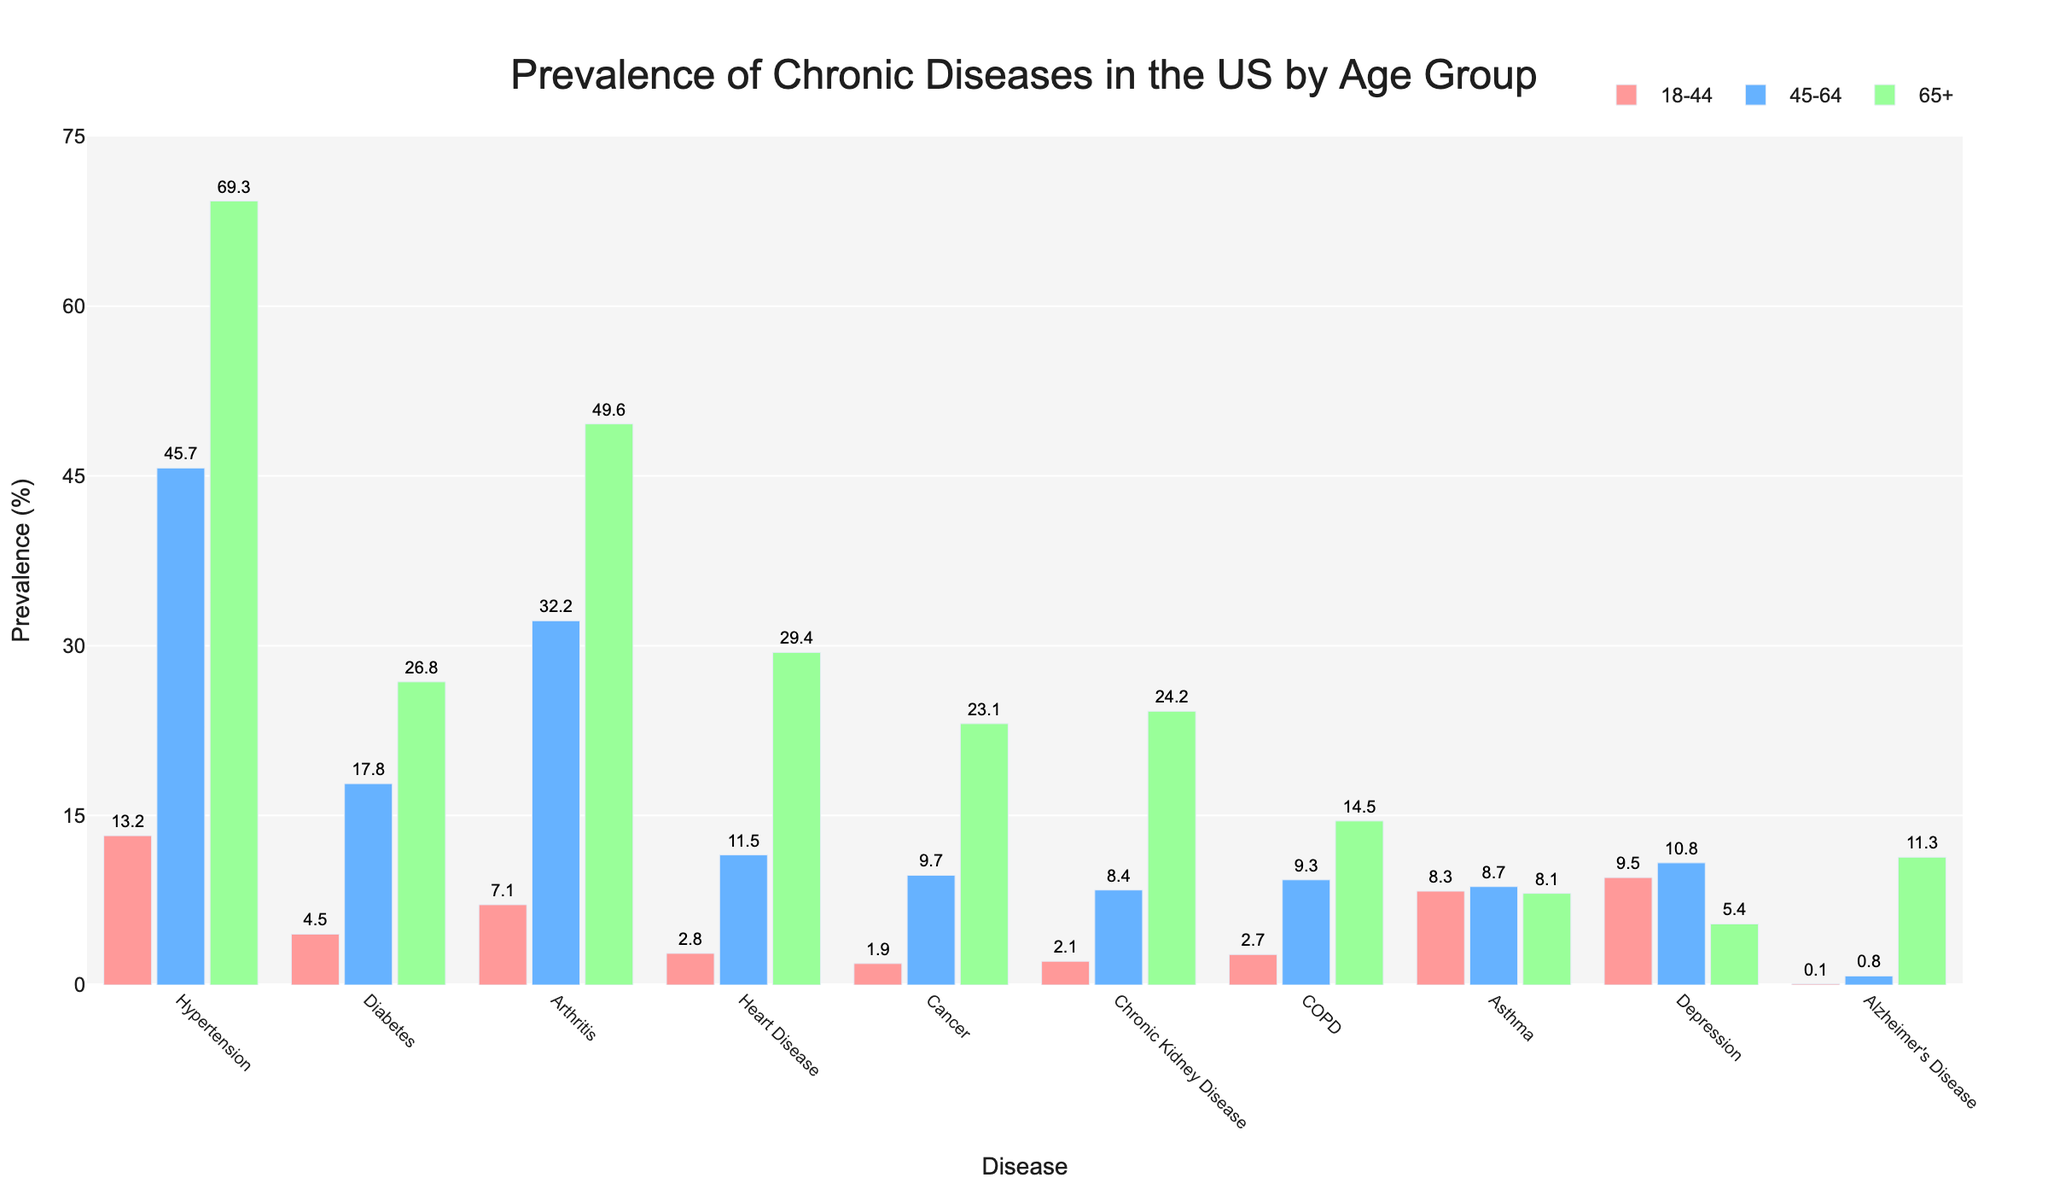Which age group has the highest prevalence of hypertension? Look for the tallest bar under the "Hypertension" category for each age group. The tallest bar corresponds to the 65+ age group.
Answer: 65+ What is the difference in asthma prevalence between the 18-44 and 65+ age groups? Identify the heights of the bars for "Asthma" under the 18-44 and 65+ age groups. The values are 8.3 for 18-44 and 8.1 for 65+. Subtract the two values: 8.3 - 8.1 = 0.2.
Answer: 0.2 Which disease has the smallest prevalence in the 45-64 age group, and what is that prevalence? Find the shortest bar within the 45-64 age group. "Alzheimer's Disease" has the shortest bar with a prevalence of 0.8.
Answer: Alzheimer's Disease, 0.8 How many diseases have a prevalence greater than 10% in the 65+ age group? Count the number of diseases with bars exceeding the 10% mark in the 65+ age group: Hypertension, Diabetes, Arthritis, Heart Disease, Cancer, Chronic Kidney Disease, COPD, Alzheimer's Disease. There are eight such diseases.
Answer: 8 Compare the prevalence of arthritis between the 18-44 and 45-64 age groups and calculate the percentage increase. The prevalence for Arthritis is 7.1 for 18-44 and 32.2 for 45-64. The percentage increase is calculated as ((32.2 - 7.1)/7.1) * 100 = 353.52%.
Answer: 353.52% What is the combined prevalence of diabetes and hypertension in the 45-64 age group? Add the prevalence of Diabetes and Hypertension for the 45-64 age group. The values are 17.8 (Diabetes) and 45.7 (Hypertension). The combined prevalence is 17.8 + 45.7 = 63.5.
Answer: 63.5 Identify the disease with the highest prevalence in 18-44 age group and specify its prevalence. Look for the tallest bar in the 18-44 age group. "Asthma" has the tallest bar with a prevalence of 8.3.
Answer: Asthma, 8.3 Compare the prevalence of depression between the 18-44 and 65+ age groups and state the difference. Identify the prevalence of Depression in both age groups. The values are 9.5 for 18-44 and 5.4 for 65+. Subtract the two values: 9.5 - 5.4 = 4.1.
Answer: 4.1 Does the prevalence of heart disease increase or decrease with age? Observe the trend in the heights of the bars for "Heart Disease" across the age groups. The bars get taller as the age group increases, indicating an increase in prevalence.
Answer: Increase 